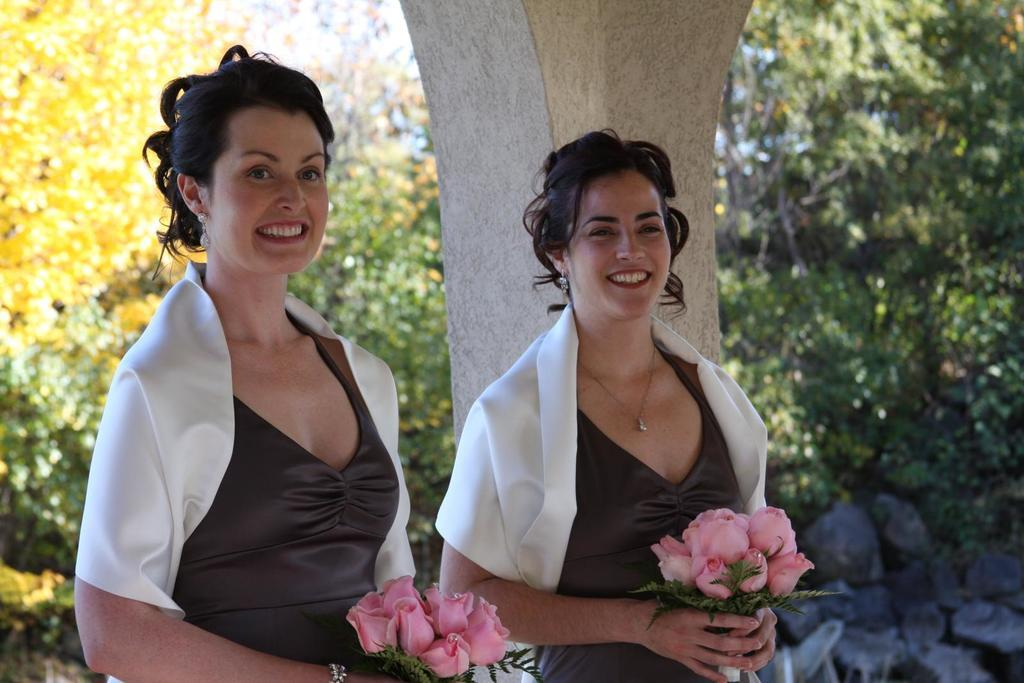How many people are in the image? There are two females in the image. What are the females holding in the image? The females are holding a flower bouquet. What can be seen in the image besides the females and the flower bouquet? There is a pillar in the image. What is visible in the background of the image? There are trees in the background of the image. What type of plane can be seen flying in the image? There is no plane visible in the image; it only features two females holding a flower bouquet, a pillar, and trees in the background. 